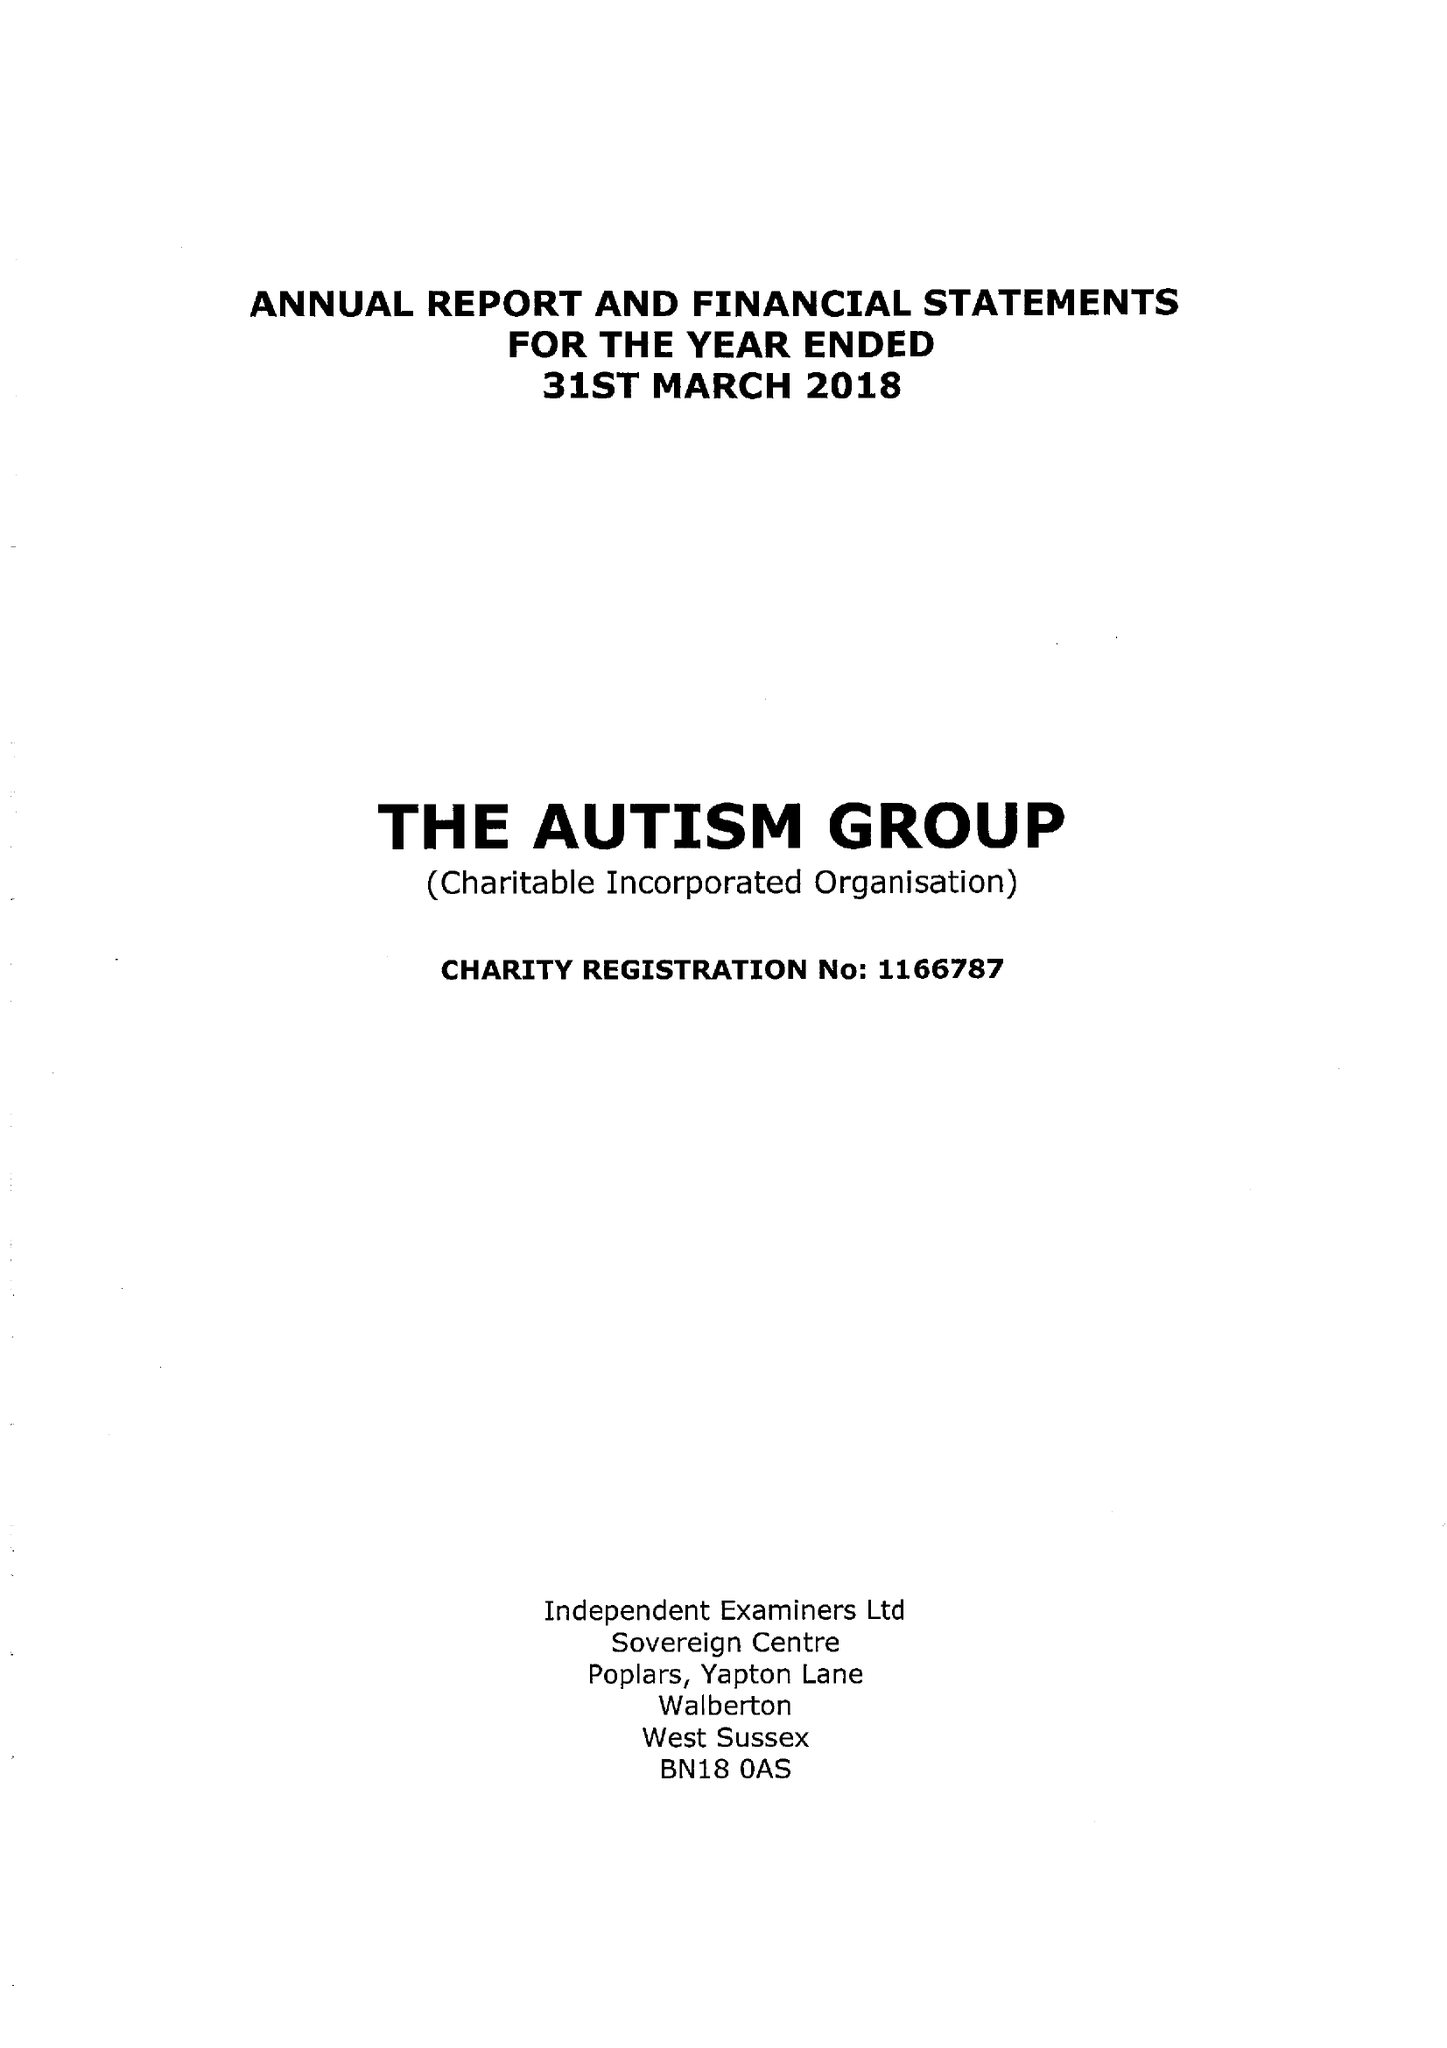What is the value for the address__post_town?
Answer the question using a single word or phrase. MAIDENHEAD 